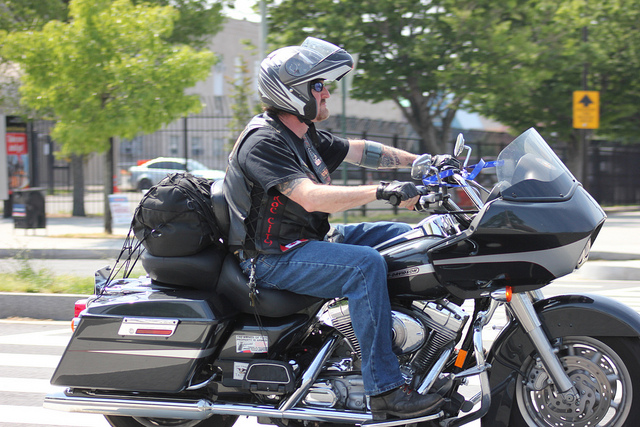What might be the destination or purpose of this ride? While it's difficult to determine the exact destination or purpose, the packed saddlebags and casual attire suggest the rider could be on a leisure trip, possibly a long-distance journey or a weekend getaway. 